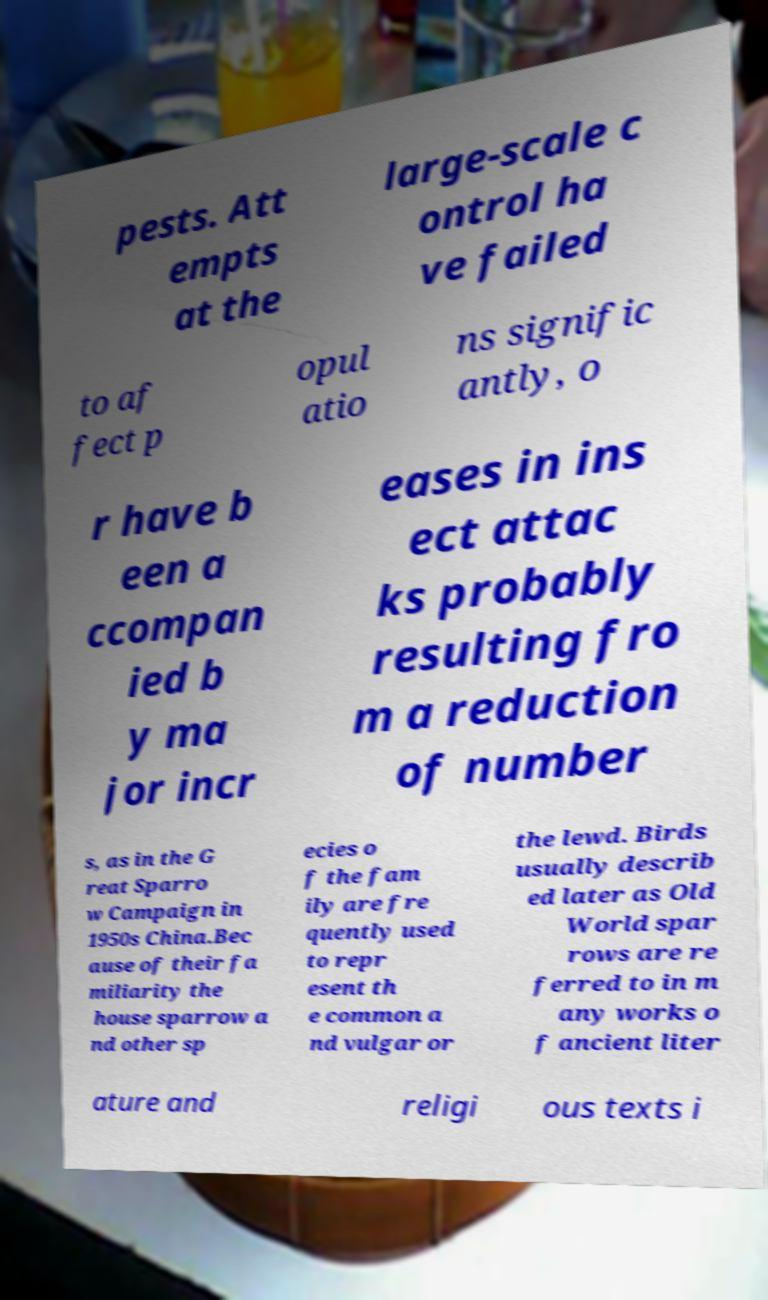Could you assist in decoding the text presented in this image and type it out clearly? pests. Att empts at the large-scale c ontrol ha ve failed to af fect p opul atio ns signific antly, o r have b een a ccompan ied b y ma jor incr eases in ins ect attac ks probably resulting fro m a reduction of number s, as in the G reat Sparro w Campaign in 1950s China.Bec ause of their fa miliarity the house sparrow a nd other sp ecies o f the fam ily are fre quently used to repr esent th e common a nd vulgar or the lewd. Birds usually describ ed later as Old World spar rows are re ferred to in m any works o f ancient liter ature and religi ous texts i 